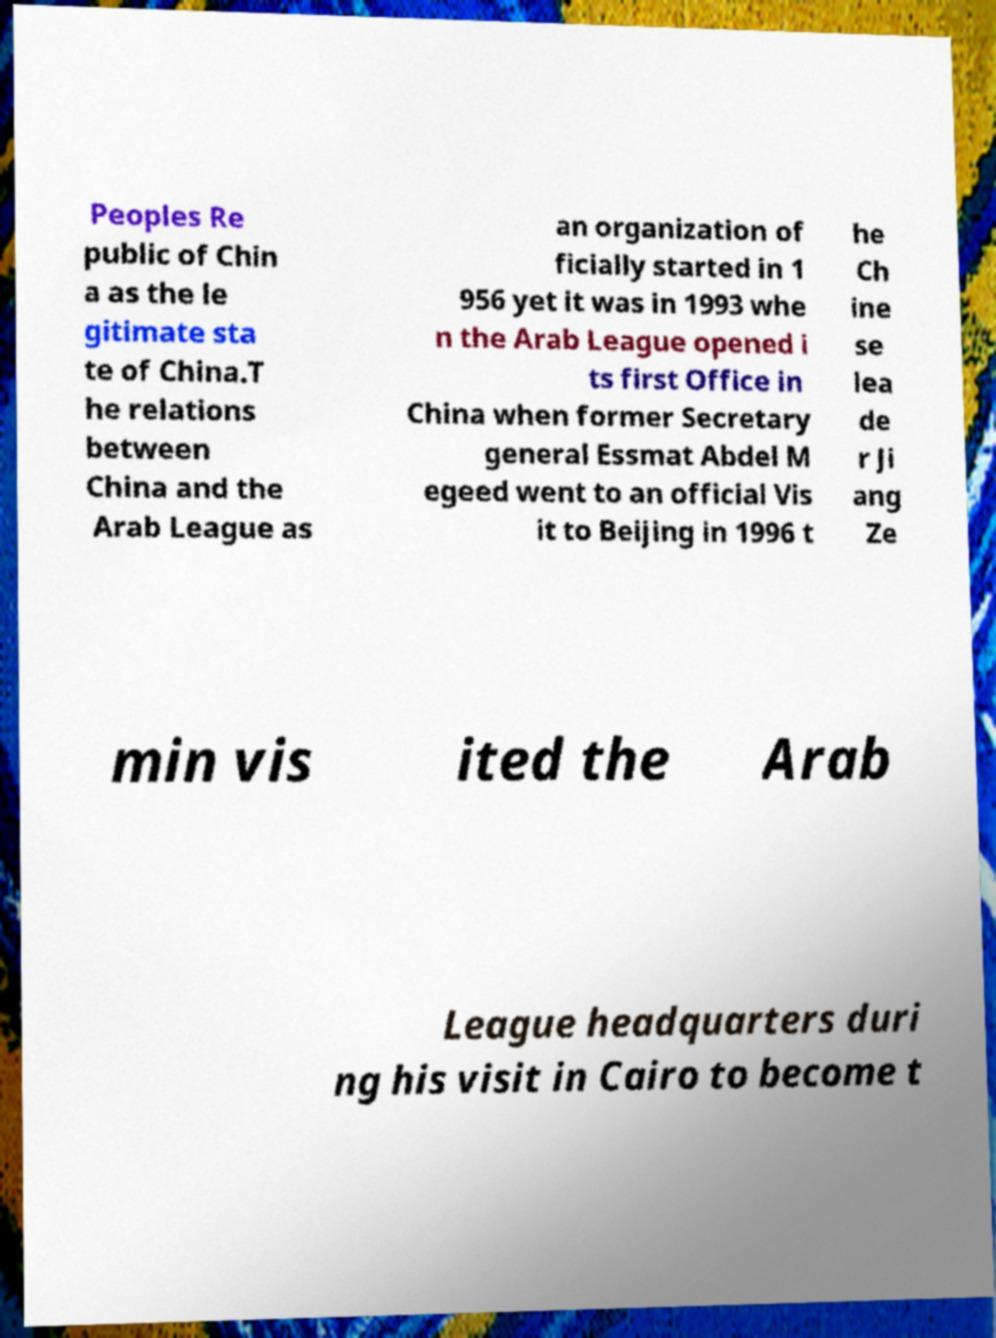Could you extract and type out the text from this image? Peoples Re public of Chin a as the le gitimate sta te of China.T he relations between China and the Arab League as an organization of ficially started in 1 956 yet it was in 1993 whe n the Arab League opened i ts first Office in China when former Secretary general Essmat Abdel M egeed went to an official Vis it to Beijing in 1996 t he Ch ine se lea de r Ji ang Ze min vis ited the Arab League headquarters duri ng his visit in Cairo to become t 